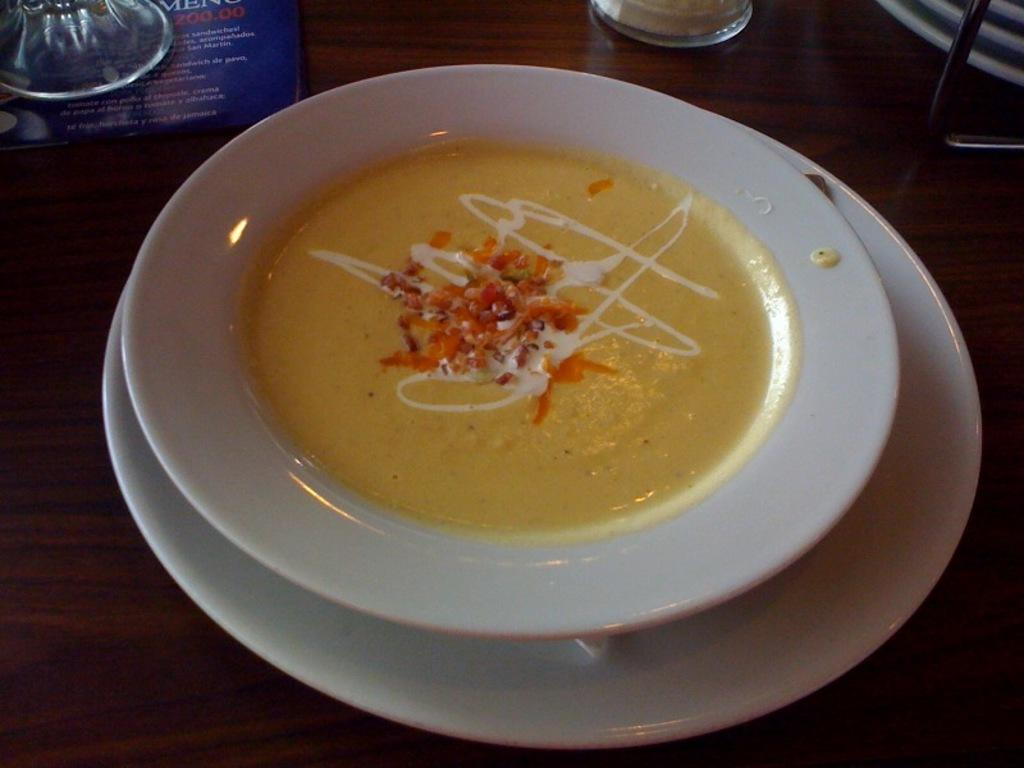What piece of furniture is present in the image? There is a table in the image. What is placed on the table? There is a plate on the table. What is on top of the plate? There is a bowl on the plate. What can be found inside the bowl? There is a food item in the bowl. Can you see a lake in the image? No, there is no lake present in the image. 